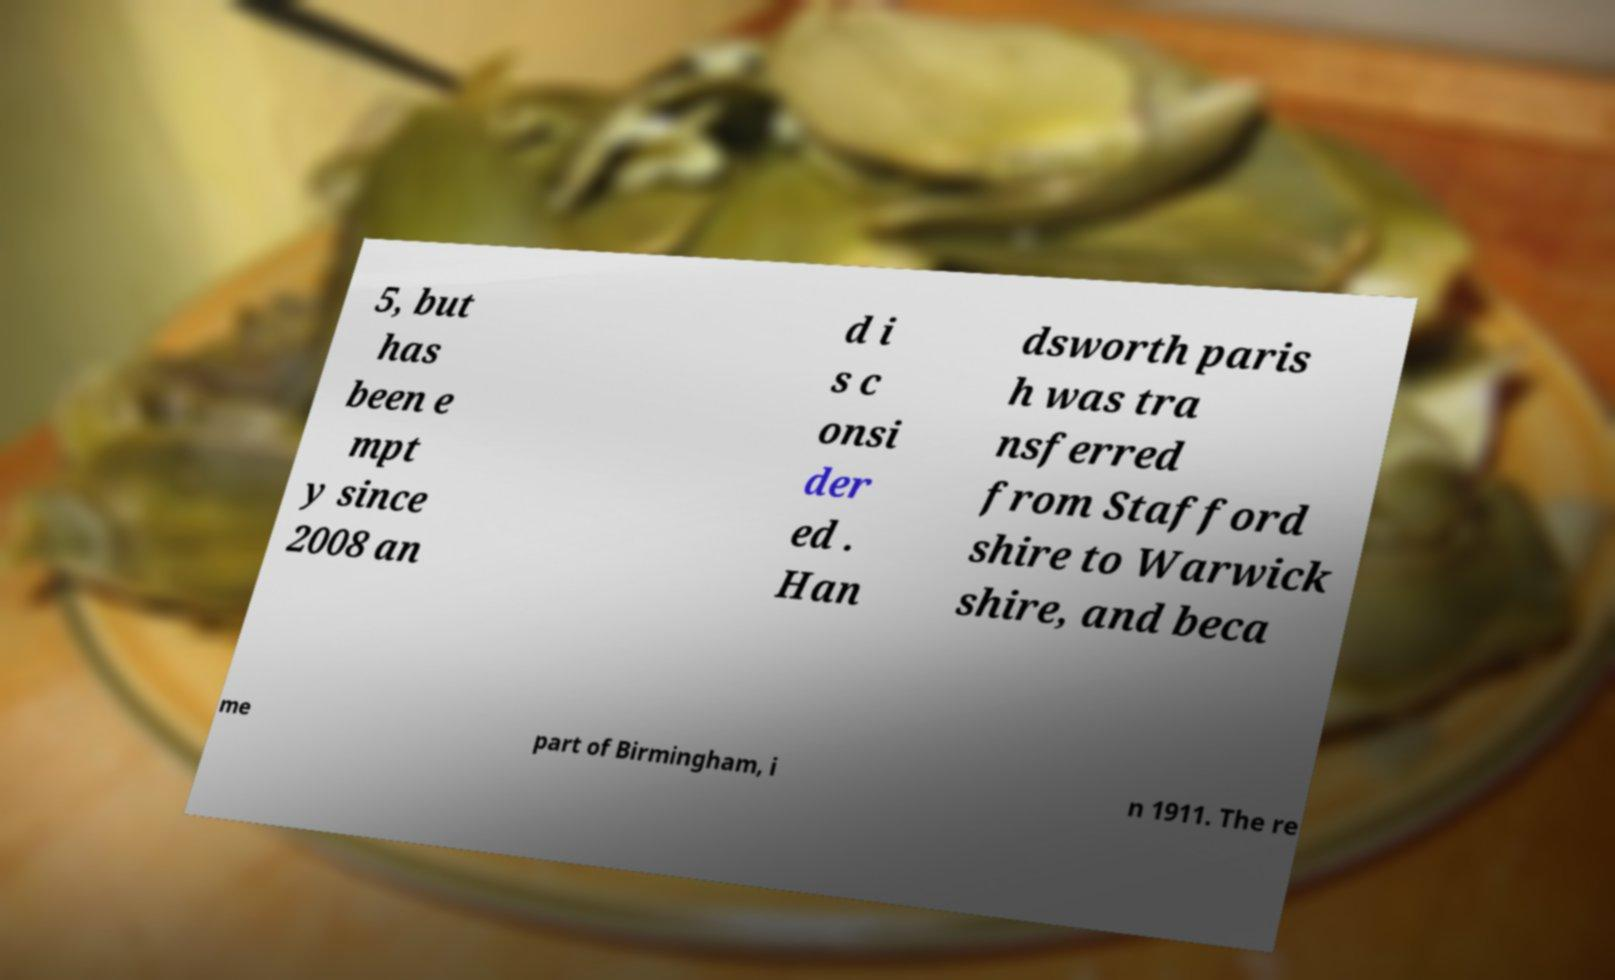Could you extract and type out the text from this image? 5, but has been e mpt y since 2008 an d i s c onsi der ed . Han dsworth paris h was tra nsferred from Stafford shire to Warwick shire, and beca me part of Birmingham, i n 1911. The re 